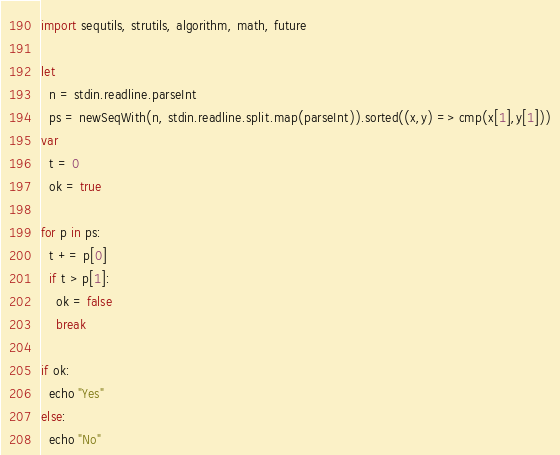<code> <loc_0><loc_0><loc_500><loc_500><_Nim_>import sequtils, strutils, algorithm, math, future

let
  n = stdin.readline.parseInt
  ps = newSeqWith(n, stdin.readline.split.map(parseInt)).sorted((x,y) => cmp(x[1],y[1]))
var
  t = 0
  ok = true

for p in ps:
  t += p[0]
  if t > p[1]:
    ok = false
    break

if ok:
  echo "Yes"
else:
  echo "No"
</code> 